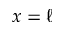<formula> <loc_0><loc_0><loc_500><loc_500>x = \ell</formula> 